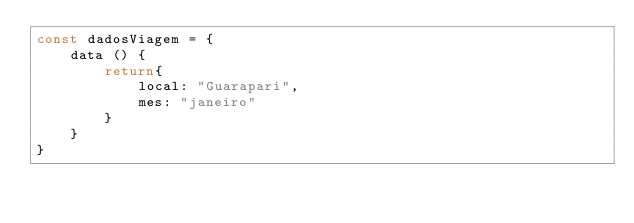Convert code to text. <code><loc_0><loc_0><loc_500><loc_500><_JavaScript_>const dadosViagem = {
    data () {
        return{
            local: "Guarapari",
            mes: "janeiro"
        }
    }
}
</code> 